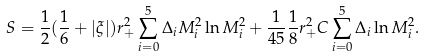<formula> <loc_0><loc_0><loc_500><loc_500>S = { \frac { 1 } { 2 } } ( { \frac { 1 } { 6 } } + | \xi | ) r _ { + } ^ { 2 } \sum _ { i = 0 } ^ { 5 } \Delta _ { i } M _ { i } ^ { 2 } \ln M _ { i } ^ { 2 } + { \frac { 1 } { 4 5 } } { \frac { 1 } { 8 } } r _ { + } ^ { 2 } C \sum _ { i = 0 } ^ { 5 } \Delta _ { i } \ln M _ { i } ^ { 2 } .</formula> 